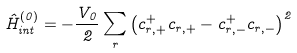<formula> <loc_0><loc_0><loc_500><loc_500>\hat { H } _ { i n t } ^ { \left ( 0 \right ) } = - \frac { V _ { 0 } } { 2 } \sum _ { r } \left ( c _ { r , + } ^ { + } c _ { r , + } - c _ { r , - } ^ { + } c _ { r , - } \right ) ^ { 2 }</formula> 